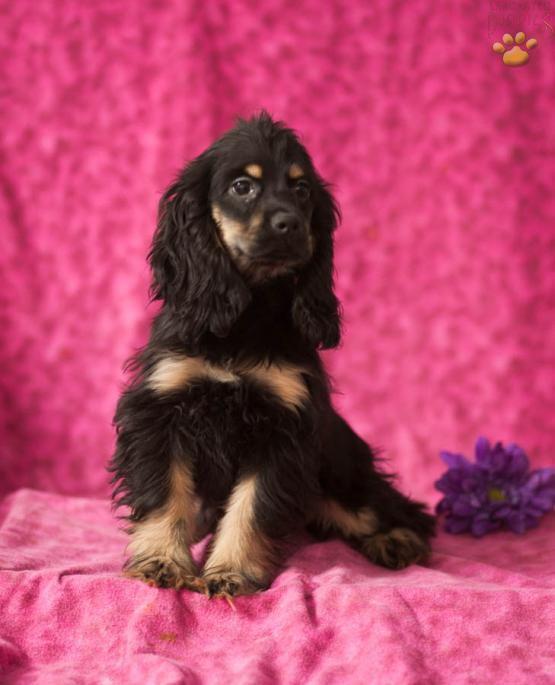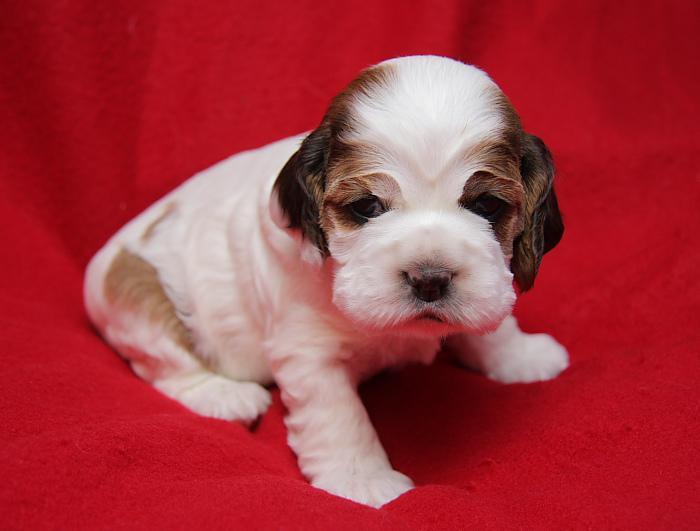The first image is the image on the left, the second image is the image on the right. Evaluate the accuracy of this statement regarding the images: "There are only two dogs in total.". Is it true? Answer yes or no. Yes. The first image is the image on the left, the second image is the image on the right. For the images shown, is this caption "Two spaniels are next to each other on a sofa in one image, and the other image shows one puppy in the foreground." true? Answer yes or no. No. 